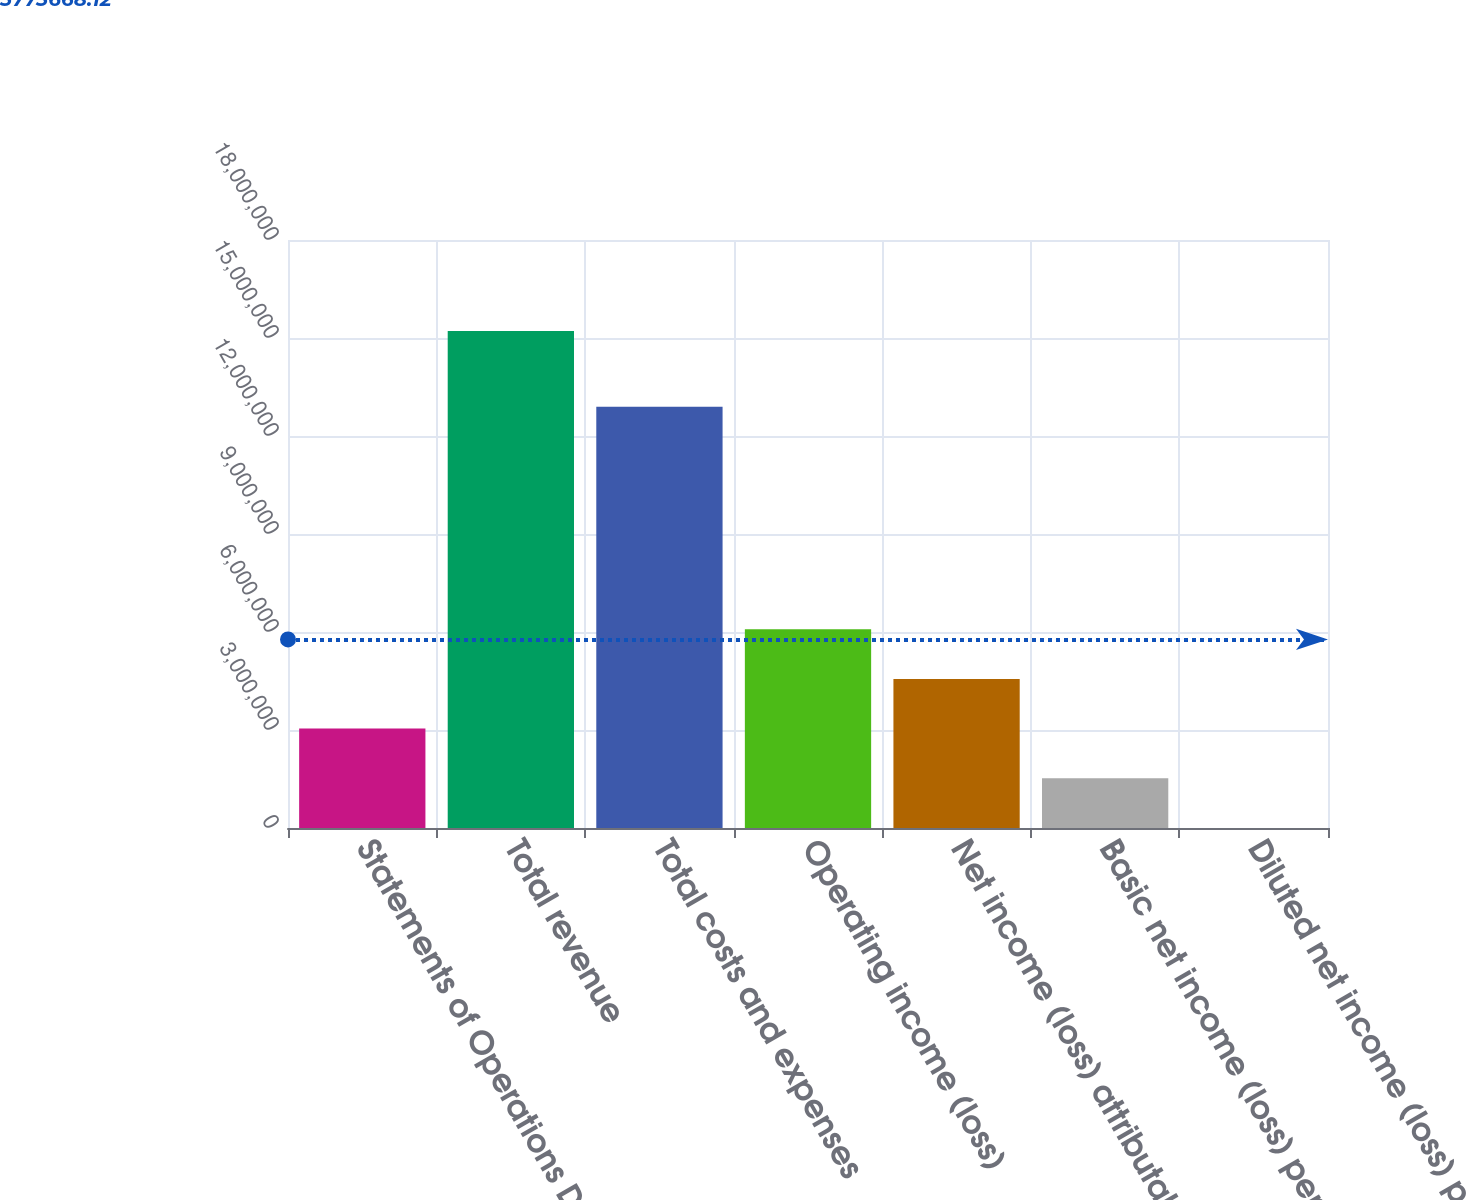<chart> <loc_0><loc_0><loc_500><loc_500><bar_chart><fcel>Statements of Operations Data<fcel>Total revenue<fcel>Total costs and expenses<fcel>Operating income (loss)<fcel>Net income (loss) attributable<fcel>Basic net income (loss) per<fcel>Diluted net income (loss) per<nl><fcel>3.04246e+06<fcel>1.52123e+07<fcel>1.2893e+07<fcel>6.08492e+06<fcel>4.56369e+06<fcel>1.52123e+06<fcel>3.15<nl></chart> 